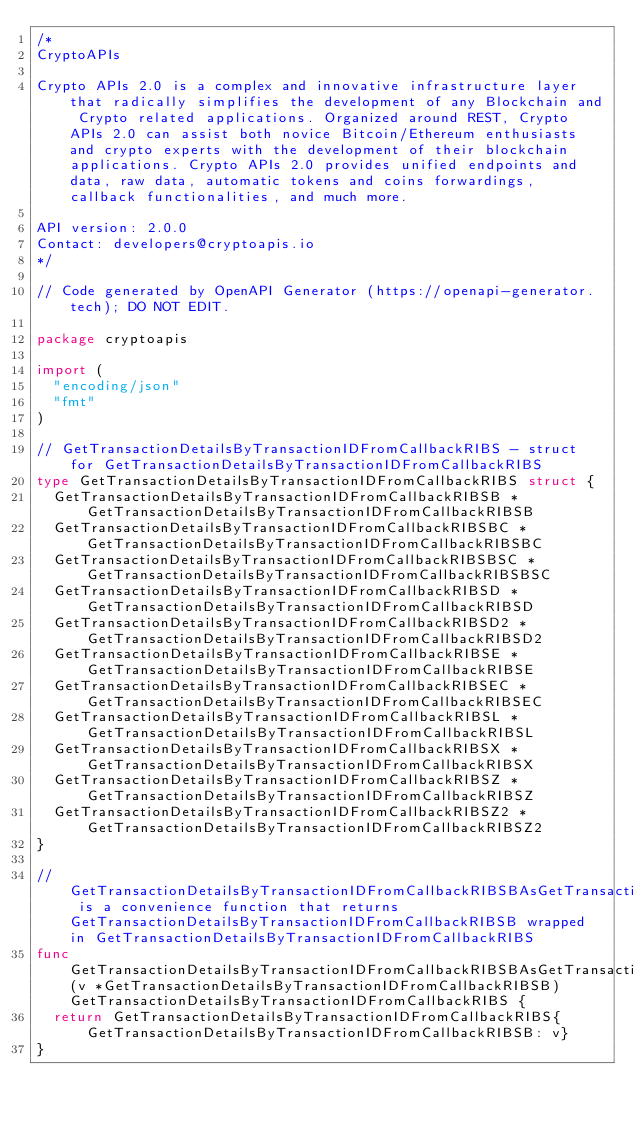<code> <loc_0><loc_0><loc_500><loc_500><_Go_>/*
CryptoAPIs

Crypto APIs 2.0 is a complex and innovative infrastructure layer that radically simplifies the development of any Blockchain and Crypto related applications. Organized around REST, Crypto APIs 2.0 can assist both novice Bitcoin/Ethereum enthusiasts and crypto experts with the development of their blockchain applications. Crypto APIs 2.0 provides unified endpoints and data, raw data, automatic tokens and coins forwardings, callback functionalities, and much more.

API version: 2.0.0
Contact: developers@cryptoapis.io
*/

// Code generated by OpenAPI Generator (https://openapi-generator.tech); DO NOT EDIT.

package cryptoapis

import (
	"encoding/json"
	"fmt"
)

// GetTransactionDetailsByTransactionIDFromCallbackRIBS - struct for GetTransactionDetailsByTransactionIDFromCallbackRIBS
type GetTransactionDetailsByTransactionIDFromCallbackRIBS struct {
	GetTransactionDetailsByTransactionIDFromCallbackRIBSB *GetTransactionDetailsByTransactionIDFromCallbackRIBSB
	GetTransactionDetailsByTransactionIDFromCallbackRIBSBC *GetTransactionDetailsByTransactionIDFromCallbackRIBSBC
	GetTransactionDetailsByTransactionIDFromCallbackRIBSBSC *GetTransactionDetailsByTransactionIDFromCallbackRIBSBSC
	GetTransactionDetailsByTransactionIDFromCallbackRIBSD *GetTransactionDetailsByTransactionIDFromCallbackRIBSD
	GetTransactionDetailsByTransactionIDFromCallbackRIBSD2 *GetTransactionDetailsByTransactionIDFromCallbackRIBSD2
	GetTransactionDetailsByTransactionIDFromCallbackRIBSE *GetTransactionDetailsByTransactionIDFromCallbackRIBSE
	GetTransactionDetailsByTransactionIDFromCallbackRIBSEC *GetTransactionDetailsByTransactionIDFromCallbackRIBSEC
	GetTransactionDetailsByTransactionIDFromCallbackRIBSL *GetTransactionDetailsByTransactionIDFromCallbackRIBSL
	GetTransactionDetailsByTransactionIDFromCallbackRIBSX *GetTransactionDetailsByTransactionIDFromCallbackRIBSX
	GetTransactionDetailsByTransactionIDFromCallbackRIBSZ *GetTransactionDetailsByTransactionIDFromCallbackRIBSZ
	GetTransactionDetailsByTransactionIDFromCallbackRIBSZ2 *GetTransactionDetailsByTransactionIDFromCallbackRIBSZ2
}

// GetTransactionDetailsByTransactionIDFromCallbackRIBSBAsGetTransactionDetailsByTransactionIDFromCallbackRIBS is a convenience function that returns GetTransactionDetailsByTransactionIDFromCallbackRIBSB wrapped in GetTransactionDetailsByTransactionIDFromCallbackRIBS
func GetTransactionDetailsByTransactionIDFromCallbackRIBSBAsGetTransactionDetailsByTransactionIDFromCallbackRIBS(v *GetTransactionDetailsByTransactionIDFromCallbackRIBSB) GetTransactionDetailsByTransactionIDFromCallbackRIBS {
	return GetTransactionDetailsByTransactionIDFromCallbackRIBS{ GetTransactionDetailsByTransactionIDFromCallbackRIBSB: v}
}
</code> 